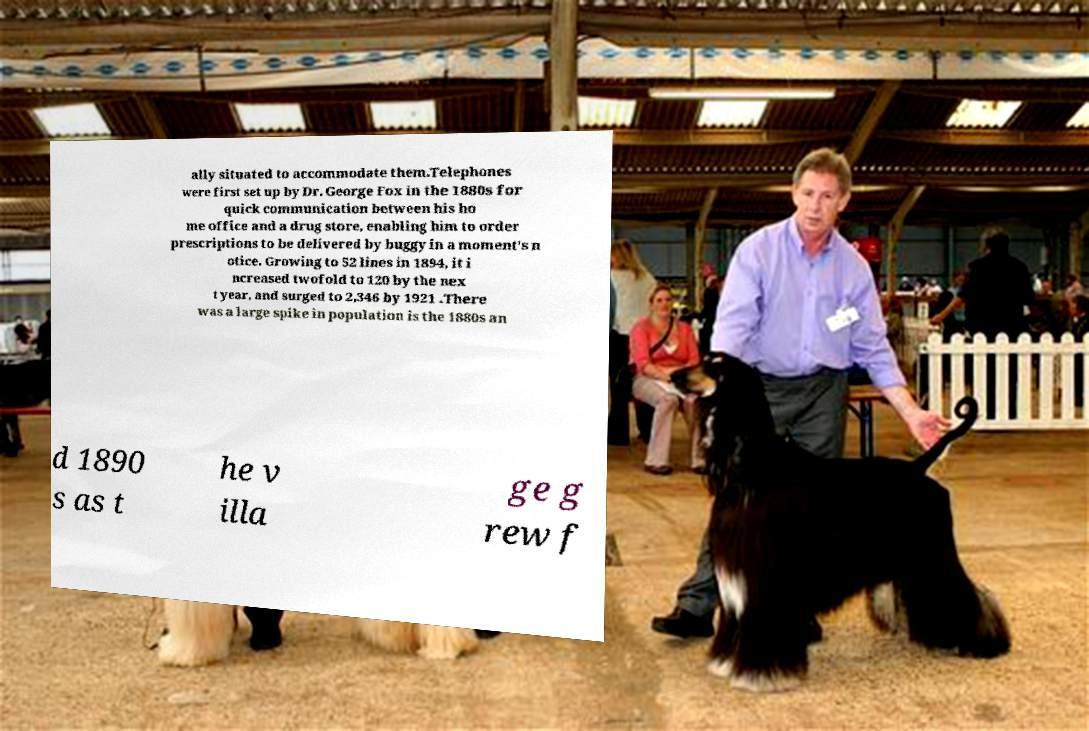I need the written content from this picture converted into text. Can you do that? ally situated to accommodate them.Telephones were first set up by Dr. George Fox in the 1880s for quick communication between his ho me office and a drug store, enabling him to order prescriptions to be delivered by buggy in a moment's n otice. Growing to 52 lines in 1894, it i ncreased twofold to 120 by the nex t year, and surged to 2,346 by 1921 .There was a large spike in population is the 1880s an d 1890 s as t he v illa ge g rew f 